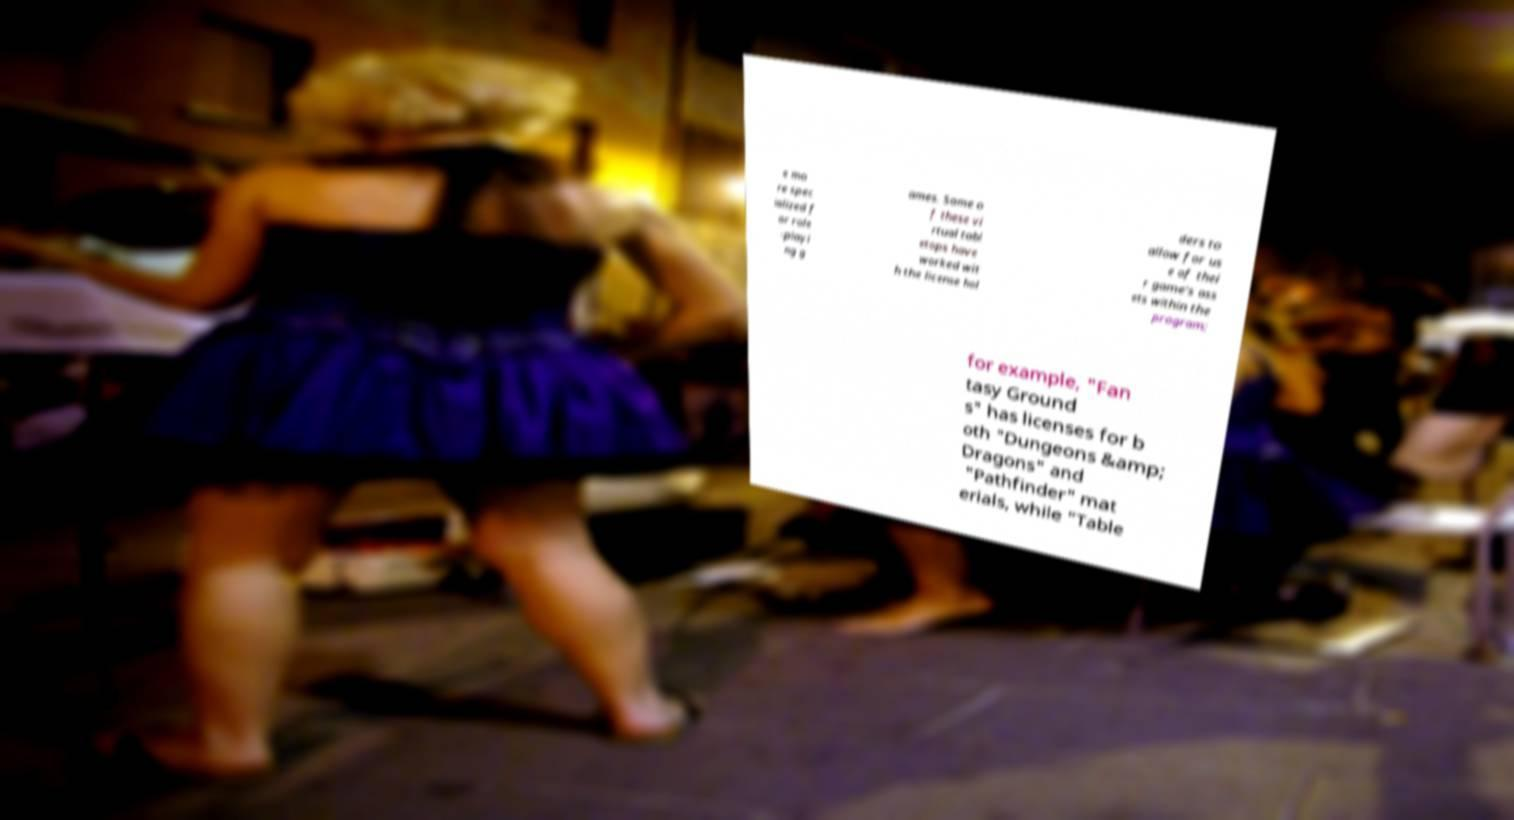For documentation purposes, I need the text within this image transcribed. Could you provide that? e mo re spec ialized f or role -playi ng g ames. Some o f these vi rtual tabl etops have worked wit h the license hol ders to allow for us e of thei r game's ass ets within the program; for example, "Fan tasy Ground s" has licenses for b oth "Dungeons &amp; Dragons" and "Pathfinder" mat erials, while "Table 